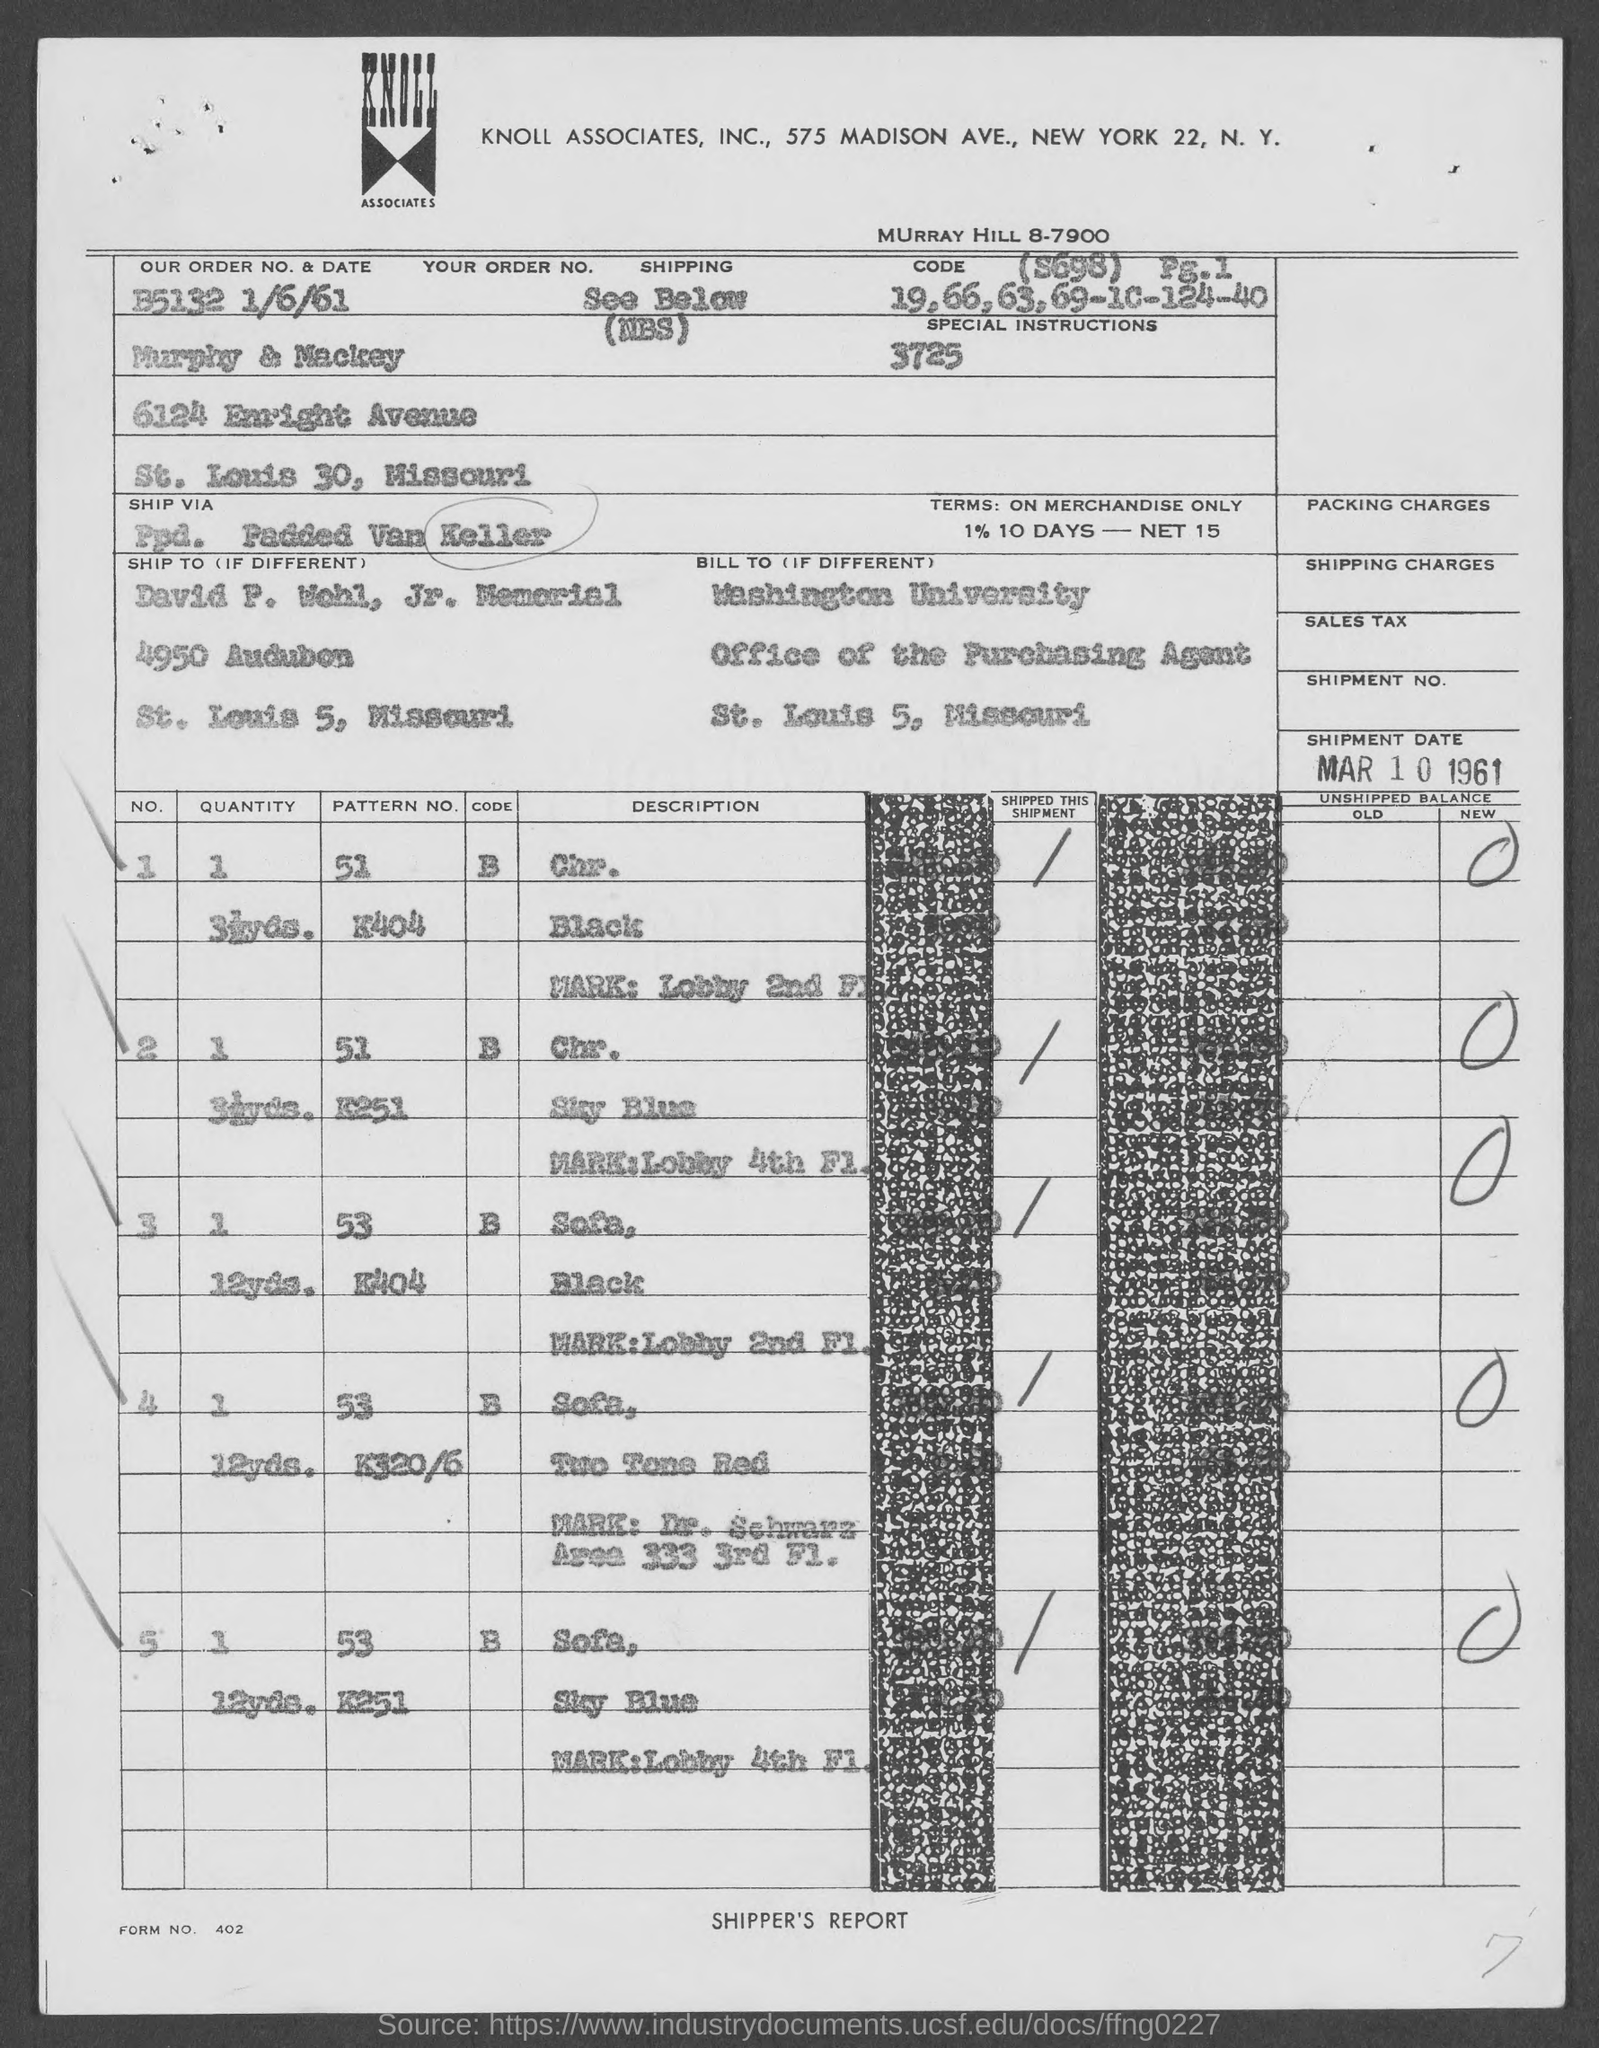Mention a couple of crucial points in this snapshot. What is form number 402..." is a question that asks for information about a specific form number. What is our order number? It is b5132... The shipment date is March 1, 1961. 